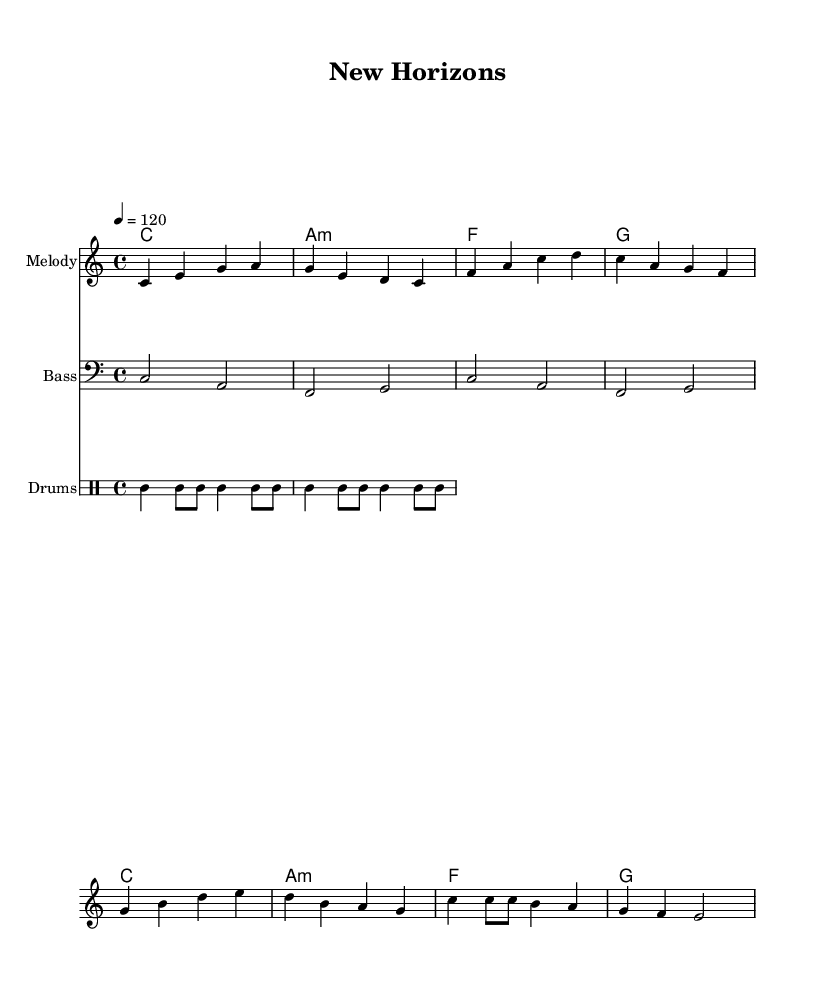What is the key signature of this music? The key signature can be determined from the section marked as `\key c \major`, which indicates that the piece is in C major, meaning there are no sharps or flats.
Answer: C major What is the time signature of this piece? The time signature can be found in the section labeled `\time 4/4`, indicating that there are four beats per measure and a quarter note receives one beat.
Answer: 4/4 What is the tempo marking in this score? The tempo is indicated by `\tempo 4 = 120`, meaning there are 120 beats per minute with each beat represented by a quarter note.
Answer: 120 How many measures are there in the melody? The melody section consists of 8 measures, which can be counted by reviewing the groups of notes divided by the vertical lines (bar lines) in the melody.
Answer: 8 What is the primary chord used in this song? The chord progression shows that C major is the first chord and appears frequently, thus making it the primary chord throughout the composition.
Answer: C What type of drums are notated in this score? The drum section indicates the use of bass drum, snare, and hi-hat, as shown by the specific notations in the `drumsPitchNames` and `drumsMusic` sections.
Answer: Bass drum, snare, hi-hat How does the bass pattern relate to the chords? The bass pattern matches the root notes of the chords indicated in the harmonies, solidifying the harmonic foundation. For example, the bass starts on C, matching the C chord.
Answer: It matches the root notes 